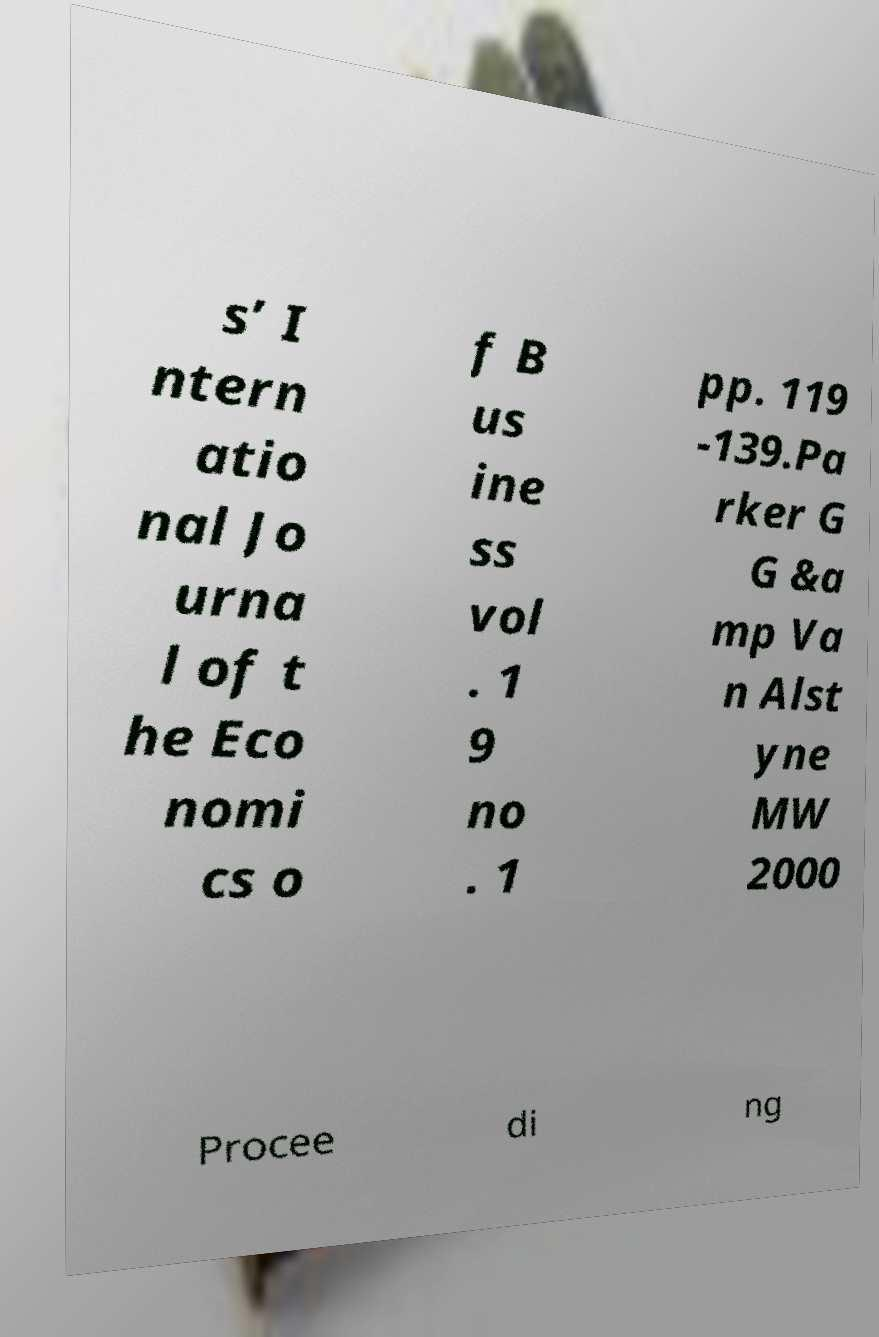There's text embedded in this image that I need extracted. Can you transcribe it verbatim? s’ I ntern atio nal Jo urna l of t he Eco nomi cs o f B us ine ss vol . 1 9 no . 1 pp. 119 -139.Pa rker G G &a mp Va n Alst yne MW 2000 Procee di ng 